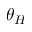Convert formula to latex. <formula><loc_0><loc_0><loc_500><loc_500>\theta _ { H }</formula> 